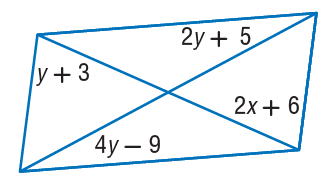Question: Find x so that the quadrilateral is a parallelogram.
Choices:
A. 2
B. 4
C. 10
D. 12
Answer with the letter. Answer: A Question: Find y so that the quadrilateral is a parallelogram.
Choices:
A. 7
B. 14
C. 15
D. 21
Answer with the letter. Answer: A 